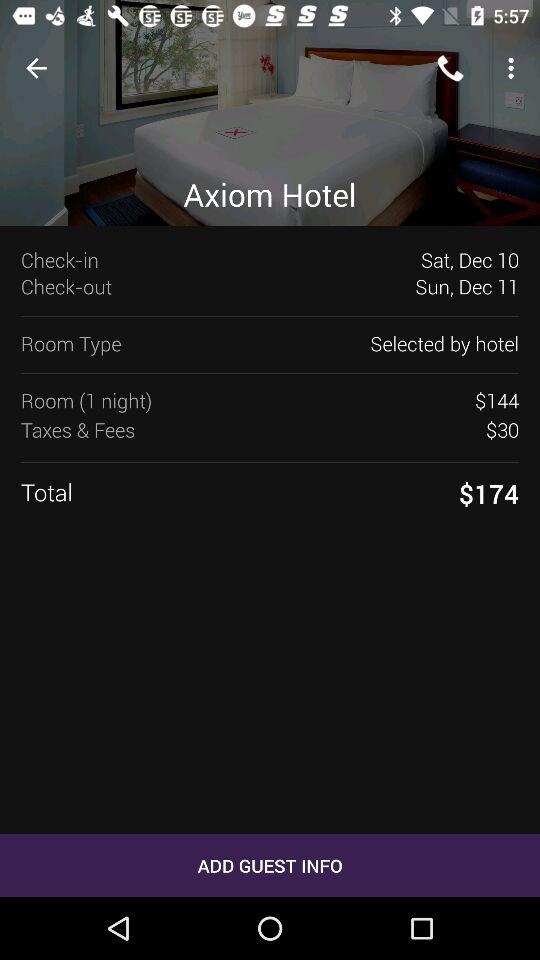What is the check-in date? The check-in date is Saturday, December 10. 